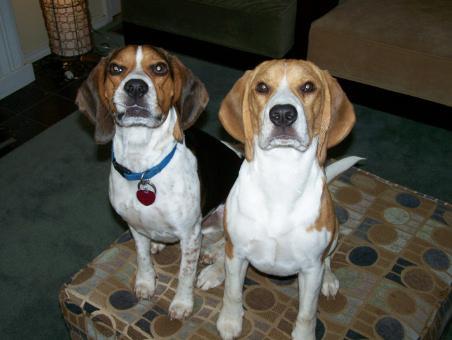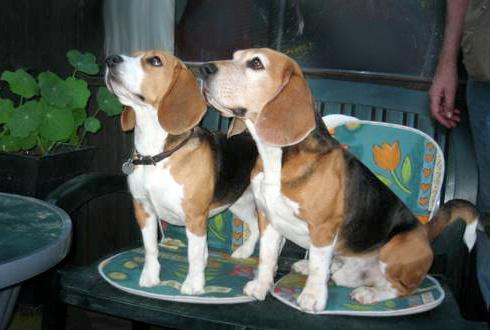The first image is the image on the left, the second image is the image on the right. For the images displayed, is the sentence "A person is behind a standing beagle, holding the base of its tail upward with one hand and propping its chin with the other." factually correct? Answer yes or no. No. 